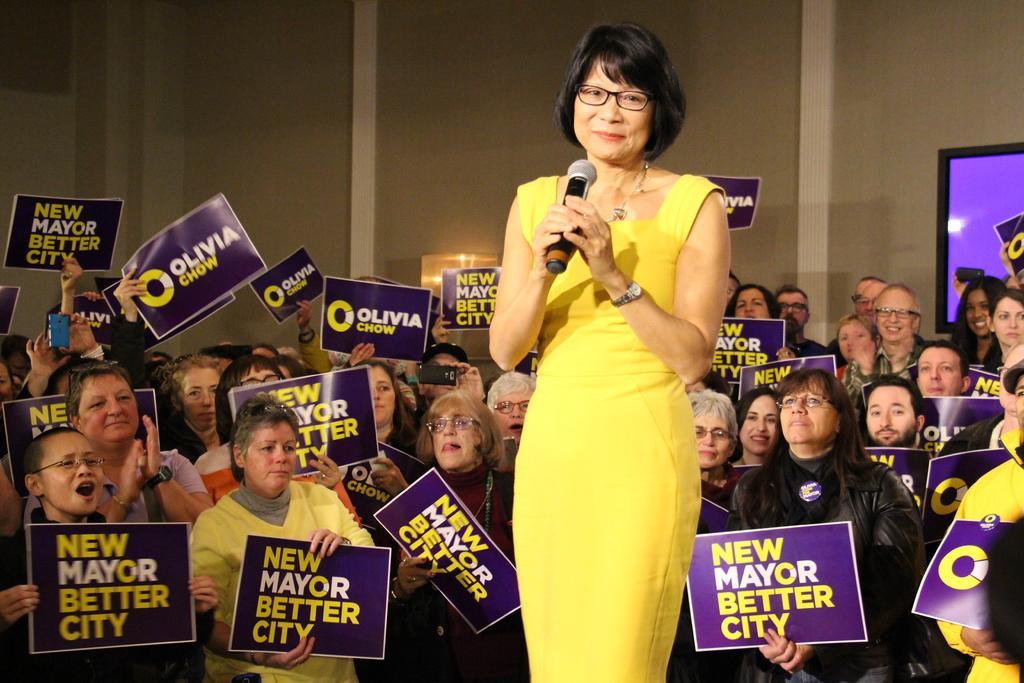Could you give a brief overview of what you see in this image? This image is taken indoors. In the background there is a wall and there is a television on the wall. Many people are standing and they are holding posters with the text on them and a few are holding mobile phones in their hands. In the middle of the image a woman is standing and she is holding a mic in her hands. 